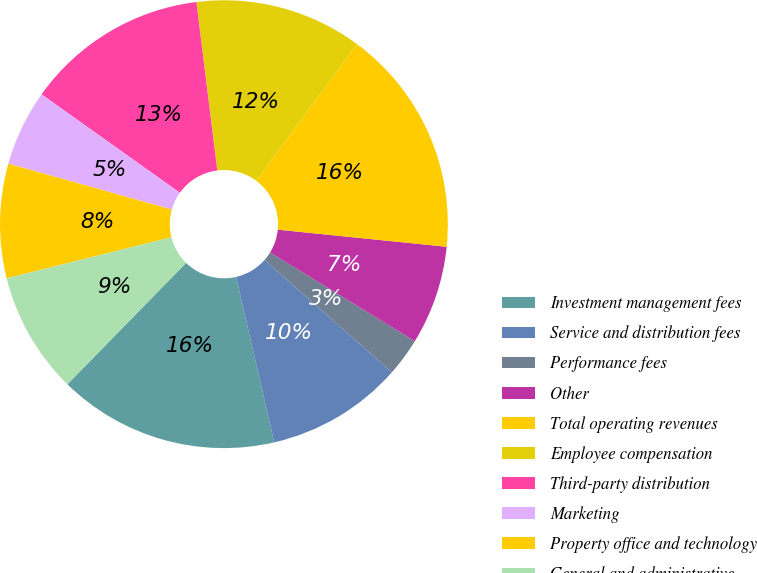Convert chart. <chart><loc_0><loc_0><loc_500><loc_500><pie_chart><fcel>Investment management fees<fcel>Service and distribution fees<fcel>Performance fees<fcel>Other<fcel>Total operating revenues<fcel>Employee compensation<fcel>Third-party distribution<fcel>Marketing<fcel>Property office and technology<fcel>General and administrative<nl><fcel>15.93%<fcel>9.89%<fcel>2.75%<fcel>7.14%<fcel>16.48%<fcel>12.09%<fcel>13.19%<fcel>5.49%<fcel>8.24%<fcel>8.79%<nl></chart> 